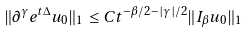<formula> <loc_0><loc_0><loc_500><loc_500>\| \partial ^ { \gamma } e ^ { t \Delta } u _ { 0 } \| _ { 1 } \leq C t ^ { - \beta / 2 - | \gamma | / 2 } \| I _ { \beta } u _ { 0 } \| _ { 1 }</formula> 